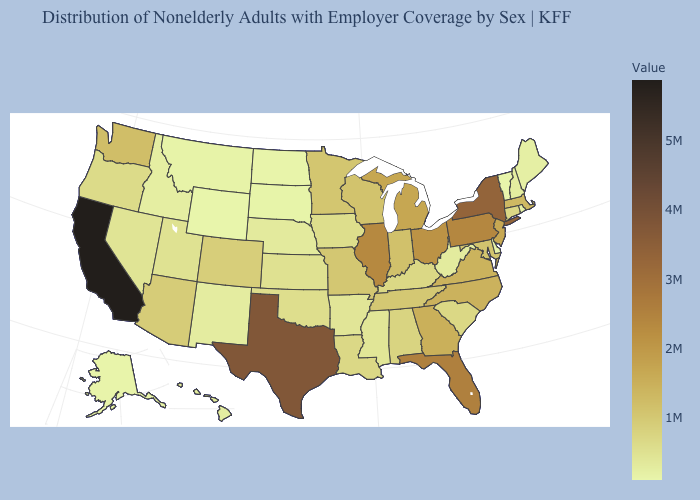Among the states that border Oklahoma , which have the highest value?
Give a very brief answer. Texas. Is the legend a continuous bar?
Write a very short answer. Yes. 